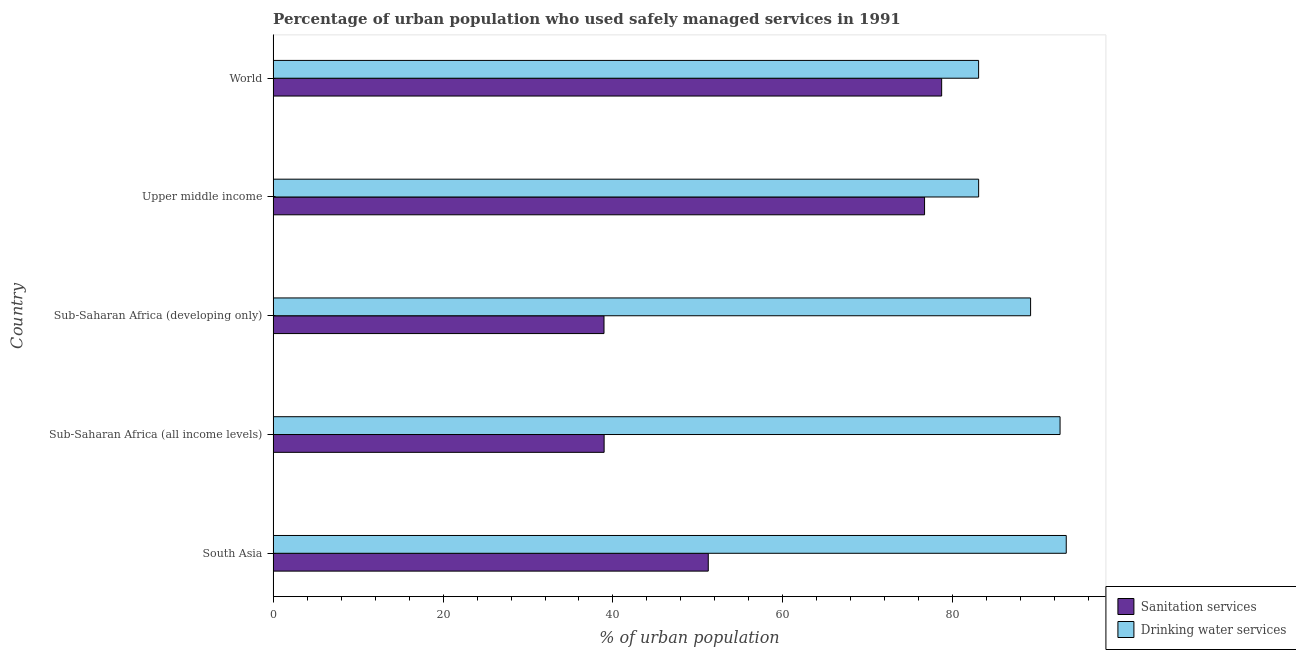How many different coloured bars are there?
Give a very brief answer. 2. How many groups of bars are there?
Offer a very short reply. 5. How many bars are there on the 1st tick from the bottom?
Offer a terse response. 2. What is the label of the 3rd group of bars from the top?
Your answer should be very brief. Sub-Saharan Africa (developing only). What is the percentage of urban population who used sanitation services in Upper middle income?
Offer a terse response. 76.68. Across all countries, what is the maximum percentage of urban population who used sanitation services?
Provide a succinct answer. 78.69. Across all countries, what is the minimum percentage of urban population who used drinking water services?
Keep it short and to the point. 83.04. In which country was the percentage of urban population who used drinking water services maximum?
Your answer should be compact. South Asia. In which country was the percentage of urban population who used sanitation services minimum?
Your answer should be very brief. Sub-Saharan Africa (developing only). What is the total percentage of urban population who used drinking water services in the graph?
Ensure brevity in your answer.  441.2. What is the difference between the percentage of urban population who used sanitation services in Sub-Saharan Africa (all income levels) and that in Sub-Saharan Africa (developing only)?
Give a very brief answer. 0.01. What is the difference between the percentage of urban population who used sanitation services in World and the percentage of urban population who used drinking water services in South Asia?
Ensure brevity in your answer.  -14.66. What is the average percentage of urban population who used sanitation services per country?
Keep it short and to the point. 56.9. What is the difference between the percentage of urban population who used drinking water services and percentage of urban population who used sanitation services in Sub-Saharan Africa (developing only)?
Provide a succinct answer. 50.21. In how many countries, is the percentage of urban population who used sanitation services greater than 60 %?
Make the answer very short. 2. What is the ratio of the percentage of urban population who used sanitation services in Sub-Saharan Africa (developing only) to that in Upper middle income?
Your answer should be very brief. 0.51. Is the percentage of urban population who used drinking water services in South Asia less than that in Sub-Saharan Africa (all income levels)?
Make the answer very short. No. What is the difference between the highest and the second highest percentage of urban population who used sanitation services?
Provide a short and direct response. 2.01. What is the difference between the highest and the lowest percentage of urban population who used drinking water services?
Provide a short and direct response. 10.31. What does the 1st bar from the top in South Asia represents?
Give a very brief answer. Drinking water services. What does the 1st bar from the bottom in South Asia represents?
Your response must be concise. Sanitation services. Are all the bars in the graph horizontal?
Give a very brief answer. Yes. Does the graph contain grids?
Offer a terse response. No. Where does the legend appear in the graph?
Your response must be concise. Bottom right. What is the title of the graph?
Make the answer very short. Percentage of urban population who used safely managed services in 1991. What is the label or title of the X-axis?
Make the answer very short. % of urban population. What is the % of urban population of Sanitation services in South Asia?
Your answer should be compact. 51.22. What is the % of urban population of Drinking water services in South Asia?
Give a very brief answer. 93.35. What is the % of urban population in Sanitation services in Sub-Saharan Africa (all income levels)?
Offer a very short reply. 38.96. What is the % of urban population in Drinking water services in Sub-Saharan Africa (all income levels)?
Ensure brevity in your answer.  92.62. What is the % of urban population in Sanitation services in Sub-Saharan Africa (developing only)?
Your answer should be very brief. 38.94. What is the % of urban population of Drinking water services in Sub-Saharan Africa (developing only)?
Ensure brevity in your answer.  89.15. What is the % of urban population in Sanitation services in Upper middle income?
Ensure brevity in your answer.  76.68. What is the % of urban population of Drinking water services in Upper middle income?
Offer a very short reply. 83.04. What is the % of urban population in Sanitation services in World?
Provide a short and direct response. 78.69. What is the % of urban population in Drinking water services in World?
Provide a short and direct response. 83.04. Across all countries, what is the maximum % of urban population of Sanitation services?
Your response must be concise. 78.69. Across all countries, what is the maximum % of urban population in Drinking water services?
Your response must be concise. 93.35. Across all countries, what is the minimum % of urban population of Sanitation services?
Make the answer very short. 38.94. Across all countries, what is the minimum % of urban population in Drinking water services?
Provide a short and direct response. 83.04. What is the total % of urban population of Sanitation services in the graph?
Your answer should be compact. 284.48. What is the total % of urban population of Drinking water services in the graph?
Your response must be concise. 441.2. What is the difference between the % of urban population in Sanitation services in South Asia and that in Sub-Saharan Africa (all income levels)?
Make the answer very short. 12.26. What is the difference between the % of urban population in Drinking water services in South Asia and that in Sub-Saharan Africa (all income levels)?
Provide a short and direct response. 0.73. What is the difference between the % of urban population of Sanitation services in South Asia and that in Sub-Saharan Africa (developing only)?
Ensure brevity in your answer.  12.27. What is the difference between the % of urban population of Drinking water services in South Asia and that in Sub-Saharan Africa (developing only)?
Offer a terse response. 4.2. What is the difference between the % of urban population of Sanitation services in South Asia and that in Upper middle income?
Your answer should be very brief. -25.46. What is the difference between the % of urban population of Drinking water services in South Asia and that in Upper middle income?
Offer a very short reply. 10.31. What is the difference between the % of urban population in Sanitation services in South Asia and that in World?
Offer a very short reply. -27.47. What is the difference between the % of urban population of Drinking water services in South Asia and that in World?
Your answer should be very brief. 10.31. What is the difference between the % of urban population of Sanitation services in Sub-Saharan Africa (all income levels) and that in Sub-Saharan Africa (developing only)?
Your answer should be compact. 0.02. What is the difference between the % of urban population in Drinking water services in Sub-Saharan Africa (all income levels) and that in Sub-Saharan Africa (developing only)?
Offer a very short reply. 3.47. What is the difference between the % of urban population in Sanitation services in Sub-Saharan Africa (all income levels) and that in Upper middle income?
Offer a terse response. -37.72. What is the difference between the % of urban population of Drinking water services in Sub-Saharan Africa (all income levels) and that in Upper middle income?
Offer a terse response. 9.58. What is the difference between the % of urban population of Sanitation services in Sub-Saharan Africa (all income levels) and that in World?
Ensure brevity in your answer.  -39.73. What is the difference between the % of urban population of Drinking water services in Sub-Saharan Africa (all income levels) and that in World?
Offer a very short reply. 9.59. What is the difference between the % of urban population of Sanitation services in Sub-Saharan Africa (developing only) and that in Upper middle income?
Give a very brief answer. -37.73. What is the difference between the % of urban population of Drinking water services in Sub-Saharan Africa (developing only) and that in Upper middle income?
Give a very brief answer. 6.11. What is the difference between the % of urban population in Sanitation services in Sub-Saharan Africa (developing only) and that in World?
Offer a terse response. -39.74. What is the difference between the % of urban population of Drinking water services in Sub-Saharan Africa (developing only) and that in World?
Ensure brevity in your answer.  6.12. What is the difference between the % of urban population in Sanitation services in Upper middle income and that in World?
Make the answer very short. -2.01. What is the difference between the % of urban population in Drinking water services in Upper middle income and that in World?
Offer a very short reply. 0. What is the difference between the % of urban population of Sanitation services in South Asia and the % of urban population of Drinking water services in Sub-Saharan Africa (all income levels)?
Offer a terse response. -41.41. What is the difference between the % of urban population in Sanitation services in South Asia and the % of urban population in Drinking water services in Sub-Saharan Africa (developing only)?
Ensure brevity in your answer.  -37.94. What is the difference between the % of urban population in Sanitation services in South Asia and the % of urban population in Drinking water services in Upper middle income?
Give a very brief answer. -31.82. What is the difference between the % of urban population of Sanitation services in South Asia and the % of urban population of Drinking water services in World?
Ensure brevity in your answer.  -31.82. What is the difference between the % of urban population of Sanitation services in Sub-Saharan Africa (all income levels) and the % of urban population of Drinking water services in Sub-Saharan Africa (developing only)?
Provide a succinct answer. -50.19. What is the difference between the % of urban population in Sanitation services in Sub-Saharan Africa (all income levels) and the % of urban population in Drinking water services in Upper middle income?
Provide a short and direct response. -44.08. What is the difference between the % of urban population in Sanitation services in Sub-Saharan Africa (all income levels) and the % of urban population in Drinking water services in World?
Your answer should be compact. -44.08. What is the difference between the % of urban population of Sanitation services in Sub-Saharan Africa (developing only) and the % of urban population of Drinking water services in Upper middle income?
Your response must be concise. -44.09. What is the difference between the % of urban population in Sanitation services in Sub-Saharan Africa (developing only) and the % of urban population in Drinking water services in World?
Your answer should be compact. -44.09. What is the difference between the % of urban population of Sanitation services in Upper middle income and the % of urban population of Drinking water services in World?
Your response must be concise. -6.36. What is the average % of urban population of Sanitation services per country?
Your answer should be very brief. 56.9. What is the average % of urban population of Drinking water services per country?
Your answer should be very brief. 88.24. What is the difference between the % of urban population of Sanitation services and % of urban population of Drinking water services in South Asia?
Keep it short and to the point. -42.13. What is the difference between the % of urban population of Sanitation services and % of urban population of Drinking water services in Sub-Saharan Africa (all income levels)?
Your answer should be compact. -53.66. What is the difference between the % of urban population in Sanitation services and % of urban population in Drinking water services in Sub-Saharan Africa (developing only)?
Your answer should be compact. -50.21. What is the difference between the % of urban population of Sanitation services and % of urban population of Drinking water services in Upper middle income?
Your answer should be very brief. -6.36. What is the difference between the % of urban population in Sanitation services and % of urban population in Drinking water services in World?
Ensure brevity in your answer.  -4.35. What is the ratio of the % of urban population in Sanitation services in South Asia to that in Sub-Saharan Africa (all income levels)?
Provide a succinct answer. 1.31. What is the ratio of the % of urban population in Sanitation services in South Asia to that in Sub-Saharan Africa (developing only)?
Your answer should be compact. 1.32. What is the ratio of the % of urban population of Drinking water services in South Asia to that in Sub-Saharan Africa (developing only)?
Offer a terse response. 1.05. What is the ratio of the % of urban population of Sanitation services in South Asia to that in Upper middle income?
Your response must be concise. 0.67. What is the ratio of the % of urban population in Drinking water services in South Asia to that in Upper middle income?
Make the answer very short. 1.12. What is the ratio of the % of urban population of Sanitation services in South Asia to that in World?
Keep it short and to the point. 0.65. What is the ratio of the % of urban population of Drinking water services in South Asia to that in World?
Keep it short and to the point. 1.12. What is the ratio of the % of urban population of Sanitation services in Sub-Saharan Africa (all income levels) to that in Sub-Saharan Africa (developing only)?
Your answer should be very brief. 1. What is the ratio of the % of urban population in Drinking water services in Sub-Saharan Africa (all income levels) to that in Sub-Saharan Africa (developing only)?
Offer a very short reply. 1.04. What is the ratio of the % of urban population of Sanitation services in Sub-Saharan Africa (all income levels) to that in Upper middle income?
Your answer should be compact. 0.51. What is the ratio of the % of urban population of Drinking water services in Sub-Saharan Africa (all income levels) to that in Upper middle income?
Offer a very short reply. 1.12. What is the ratio of the % of urban population in Sanitation services in Sub-Saharan Africa (all income levels) to that in World?
Ensure brevity in your answer.  0.5. What is the ratio of the % of urban population of Drinking water services in Sub-Saharan Africa (all income levels) to that in World?
Provide a short and direct response. 1.12. What is the ratio of the % of urban population of Sanitation services in Sub-Saharan Africa (developing only) to that in Upper middle income?
Give a very brief answer. 0.51. What is the ratio of the % of urban population of Drinking water services in Sub-Saharan Africa (developing only) to that in Upper middle income?
Keep it short and to the point. 1.07. What is the ratio of the % of urban population in Sanitation services in Sub-Saharan Africa (developing only) to that in World?
Give a very brief answer. 0.49. What is the ratio of the % of urban population in Drinking water services in Sub-Saharan Africa (developing only) to that in World?
Keep it short and to the point. 1.07. What is the ratio of the % of urban population in Sanitation services in Upper middle income to that in World?
Your answer should be compact. 0.97. What is the ratio of the % of urban population of Drinking water services in Upper middle income to that in World?
Keep it short and to the point. 1. What is the difference between the highest and the second highest % of urban population in Sanitation services?
Your answer should be compact. 2.01. What is the difference between the highest and the second highest % of urban population of Drinking water services?
Provide a succinct answer. 0.73. What is the difference between the highest and the lowest % of urban population of Sanitation services?
Your response must be concise. 39.74. What is the difference between the highest and the lowest % of urban population in Drinking water services?
Ensure brevity in your answer.  10.31. 